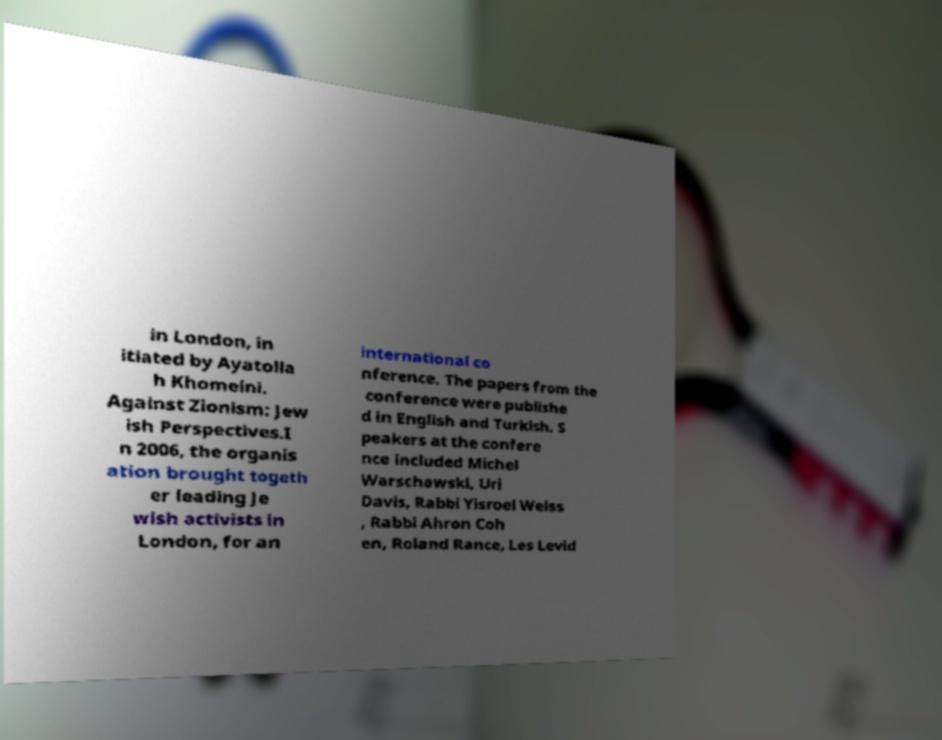Could you assist in decoding the text presented in this image and type it out clearly? in London, in itiated by Ayatolla h Khomeini. Against Zionism: Jew ish Perspectives.I n 2006, the organis ation brought togeth er leading Je wish activists in London, for an international co nference. The papers from the conference were publishe d in English and Turkish. S peakers at the confere nce included Michel Warschawski, Uri Davis, Rabbi Yisroel Weiss , Rabbi Ahron Coh en, Roland Rance, Les Levid 